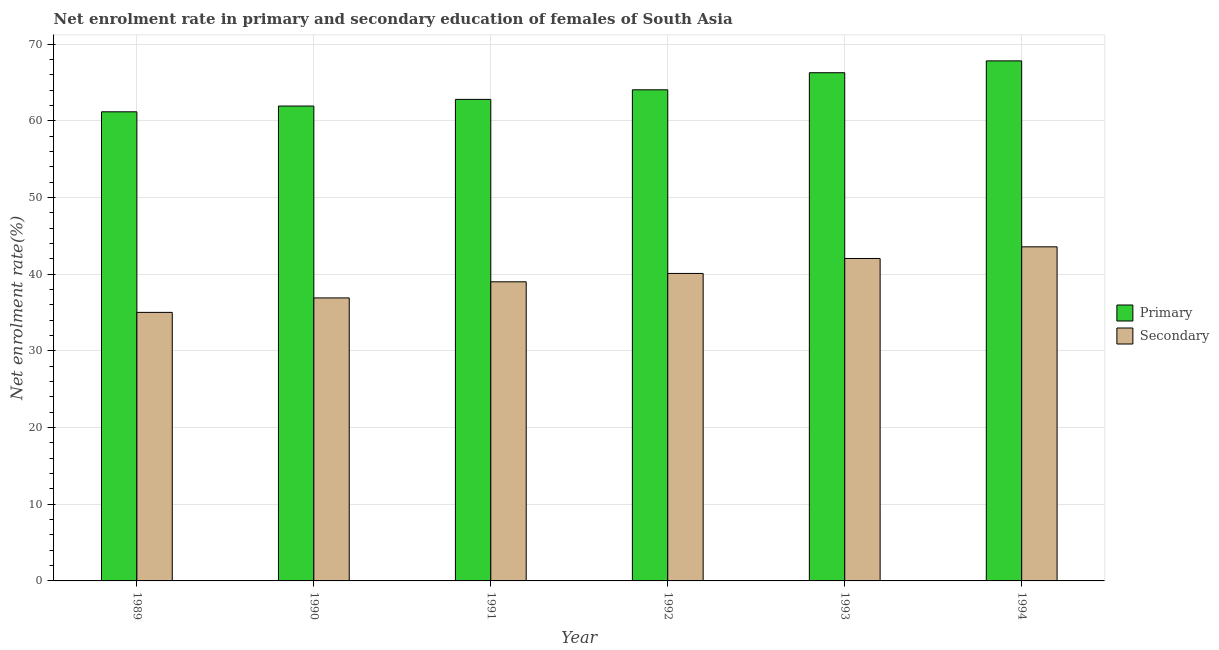How many different coloured bars are there?
Keep it short and to the point. 2. Are the number of bars per tick equal to the number of legend labels?
Your answer should be very brief. Yes. How many bars are there on the 5th tick from the left?
Your answer should be compact. 2. What is the label of the 6th group of bars from the left?
Ensure brevity in your answer.  1994. In how many cases, is the number of bars for a given year not equal to the number of legend labels?
Your response must be concise. 0. What is the enrollment rate in primary education in 1994?
Your answer should be very brief. 67.82. Across all years, what is the maximum enrollment rate in secondary education?
Offer a very short reply. 43.57. Across all years, what is the minimum enrollment rate in secondary education?
Ensure brevity in your answer.  35.02. In which year was the enrollment rate in secondary education maximum?
Your answer should be compact. 1994. In which year was the enrollment rate in primary education minimum?
Offer a terse response. 1989. What is the total enrollment rate in primary education in the graph?
Give a very brief answer. 384.06. What is the difference between the enrollment rate in primary education in 1990 and that in 1991?
Provide a short and direct response. -0.87. What is the difference between the enrollment rate in secondary education in 1990 and the enrollment rate in primary education in 1991?
Offer a very short reply. -2.1. What is the average enrollment rate in secondary education per year?
Your response must be concise. 39.44. In how many years, is the enrollment rate in primary education greater than 18 %?
Keep it short and to the point. 6. What is the ratio of the enrollment rate in secondary education in 1989 to that in 1991?
Your response must be concise. 0.9. What is the difference between the highest and the second highest enrollment rate in secondary education?
Your response must be concise. 1.52. What is the difference between the highest and the lowest enrollment rate in primary education?
Ensure brevity in your answer.  6.64. Is the sum of the enrollment rate in secondary education in 1993 and 1994 greater than the maximum enrollment rate in primary education across all years?
Your answer should be compact. Yes. What does the 1st bar from the left in 1989 represents?
Give a very brief answer. Primary. What does the 2nd bar from the right in 1992 represents?
Make the answer very short. Primary. How many bars are there?
Provide a succinct answer. 12. Are all the bars in the graph horizontal?
Provide a short and direct response. No. What is the difference between two consecutive major ticks on the Y-axis?
Offer a terse response. 10. Does the graph contain any zero values?
Ensure brevity in your answer.  No. How many legend labels are there?
Your answer should be compact. 2. What is the title of the graph?
Offer a very short reply. Net enrolment rate in primary and secondary education of females of South Asia. What is the label or title of the X-axis?
Give a very brief answer. Year. What is the label or title of the Y-axis?
Provide a succinct answer. Net enrolment rate(%). What is the Net enrolment rate(%) of Primary in 1989?
Your response must be concise. 61.18. What is the Net enrolment rate(%) in Secondary in 1989?
Your answer should be compact. 35.02. What is the Net enrolment rate(%) of Primary in 1990?
Give a very brief answer. 61.93. What is the Net enrolment rate(%) of Secondary in 1990?
Provide a short and direct response. 36.91. What is the Net enrolment rate(%) in Primary in 1991?
Offer a terse response. 62.8. What is the Net enrolment rate(%) in Secondary in 1991?
Make the answer very short. 39.01. What is the Net enrolment rate(%) of Primary in 1992?
Your answer should be compact. 64.05. What is the Net enrolment rate(%) in Secondary in 1992?
Your answer should be compact. 40.1. What is the Net enrolment rate(%) of Primary in 1993?
Ensure brevity in your answer.  66.28. What is the Net enrolment rate(%) in Secondary in 1993?
Give a very brief answer. 42.05. What is the Net enrolment rate(%) of Primary in 1994?
Provide a succinct answer. 67.82. What is the Net enrolment rate(%) of Secondary in 1994?
Give a very brief answer. 43.57. Across all years, what is the maximum Net enrolment rate(%) of Primary?
Give a very brief answer. 67.82. Across all years, what is the maximum Net enrolment rate(%) of Secondary?
Make the answer very short. 43.57. Across all years, what is the minimum Net enrolment rate(%) of Primary?
Make the answer very short. 61.18. Across all years, what is the minimum Net enrolment rate(%) of Secondary?
Provide a succinct answer. 35.02. What is the total Net enrolment rate(%) of Primary in the graph?
Offer a terse response. 384.06. What is the total Net enrolment rate(%) in Secondary in the graph?
Your response must be concise. 236.66. What is the difference between the Net enrolment rate(%) in Primary in 1989 and that in 1990?
Your answer should be very brief. -0.75. What is the difference between the Net enrolment rate(%) in Secondary in 1989 and that in 1990?
Your answer should be compact. -1.89. What is the difference between the Net enrolment rate(%) in Primary in 1989 and that in 1991?
Your response must be concise. -1.62. What is the difference between the Net enrolment rate(%) in Secondary in 1989 and that in 1991?
Offer a terse response. -3.99. What is the difference between the Net enrolment rate(%) in Primary in 1989 and that in 1992?
Provide a succinct answer. -2.87. What is the difference between the Net enrolment rate(%) in Secondary in 1989 and that in 1992?
Keep it short and to the point. -5.08. What is the difference between the Net enrolment rate(%) of Primary in 1989 and that in 1993?
Provide a succinct answer. -5.1. What is the difference between the Net enrolment rate(%) in Secondary in 1989 and that in 1993?
Your response must be concise. -7.03. What is the difference between the Net enrolment rate(%) in Primary in 1989 and that in 1994?
Provide a succinct answer. -6.64. What is the difference between the Net enrolment rate(%) of Secondary in 1989 and that in 1994?
Offer a very short reply. -8.55. What is the difference between the Net enrolment rate(%) in Primary in 1990 and that in 1991?
Ensure brevity in your answer.  -0.87. What is the difference between the Net enrolment rate(%) of Secondary in 1990 and that in 1991?
Offer a very short reply. -2.1. What is the difference between the Net enrolment rate(%) in Primary in 1990 and that in 1992?
Your answer should be very brief. -2.12. What is the difference between the Net enrolment rate(%) of Secondary in 1990 and that in 1992?
Your answer should be very brief. -3.19. What is the difference between the Net enrolment rate(%) in Primary in 1990 and that in 1993?
Offer a terse response. -4.35. What is the difference between the Net enrolment rate(%) of Secondary in 1990 and that in 1993?
Your answer should be compact. -5.14. What is the difference between the Net enrolment rate(%) in Primary in 1990 and that in 1994?
Your answer should be compact. -5.89. What is the difference between the Net enrolment rate(%) of Secondary in 1990 and that in 1994?
Make the answer very short. -6.66. What is the difference between the Net enrolment rate(%) of Primary in 1991 and that in 1992?
Make the answer very short. -1.25. What is the difference between the Net enrolment rate(%) in Secondary in 1991 and that in 1992?
Your response must be concise. -1.09. What is the difference between the Net enrolment rate(%) of Primary in 1991 and that in 1993?
Your answer should be very brief. -3.48. What is the difference between the Net enrolment rate(%) in Secondary in 1991 and that in 1993?
Make the answer very short. -3.04. What is the difference between the Net enrolment rate(%) in Primary in 1991 and that in 1994?
Your answer should be very brief. -5.02. What is the difference between the Net enrolment rate(%) in Secondary in 1991 and that in 1994?
Your answer should be very brief. -4.56. What is the difference between the Net enrolment rate(%) of Primary in 1992 and that in 1993?
Give a very brief answer. -2.23. What is the difference between the Net enrolment rate(%) in Secondary in 1992 and that in 1993?
Provide a succinct answer. -1.95. What is the difference between the Net enrolment rate(%) in Primary in 1992 and that in 1994?
Provide a short and direct response. -3.77. What is the difference between the Net enrolment rate(%) in Secondary in 1992 and that in 1994?
Make the answer very short. -3.47. What is the difference between the Net enrolment rate(%) in Primary in 1993 and that in 1994?
Your answer should be compact. -1.54. What is the difference between the Net enrolment rate(%) of Secondary in 1993 and that in 1994?
Your answer should be very brief. -1.52. What is the difference between the Net enrolment rate(%) in Primary in 1989 and the Net enrolment rate(%) in Secondary in 1990?
Keep it short and to the point. 24.27. What is the difference between the Net enrolment rate(%) of Primary in 1989 and the Net enrolment rate(%) of Secondary in 1991?
Keep it short and to the point. 22.17. What is the difference between the Net enrolment rate(%) in Primary in 1989 and the Net enrolment rate(%) in Secondary in 1992?
Provide a short and direct response. 21.08. What is the difference between the Net enrolment rate(%) in Primary in 1989 and the Net enrolment rate(%) in Secondary in 1993?
Your response must be concise. 19.13. What is the difference between the Net enrolment rate(%) in Primary in 1989 and the Net enrolment rate(%) in Secondary in 1994?
Your response must be concise. 17.61. What is the difference between the Net enrolment rate(%) in Primary in 1990 and the Net enrolment rate(%) in Secondary in 1991?
Offer a terse response. 22.92. What is the difference between the Net enrolment rate(%) in Primary in 1990 and the Net enrolment rate(%) in Secondary in 1992?
Ensure brevity in your answer.  21.83. What is the difference between the Net enrolment rate(%) of Primary in 1990 and the Net enrolment rate(%) of Secondary in 1993?
Your answer should be compact. 19.88. What is the difference between the Net enrolment rate(%) in Primary in 1990 and the Net enrolment rate(%) in Secondary in 1994?
Ensure brevity in your answer.  18.36. What is the difference between the Net enrolment rate(%) of Primary in 1991 and the Net enrolment rate(%) of Secondary in 1992?
Make the answer very short. 22.7. What is the difference between the Net enrolment rate(%) in Primary in 1991 and the Net enrolment rate(%) in Secondary in 1993?
Provide a short and direct response. 20.75. What is the difference between the Net enrolment rate(%) in Primary in 1991 and the Net enrolment rate(%) in Secondary in 1994?
Provide a succinct answer. 19.23. What is the difference between the Net enrolment rate(%) in Primary in 1992 and the Net enrolment rate(%) in Secondary in 1993?
Your answer should be very brief. 22. What is the difference between the Net enrolment rate(%) of Primary in 1992 and the Net enrolment rate(%) of Secondary in 1994?
Give a very brief answer. 20.48. What is the difference between the Net enrolment rate(%) of Primary in 1993 and the Net enrolment rate(%) of Secondary in 1994?
Offer a terse response. 22.71. What is the average Net enrolment rate(%) in Primary per year?
Keep it short and to the point. 64.01. What is the average Net enrolment rate(%) of Secondary per year?
Ensure brevity in your answer.  39.44. In the year 1989, what is the difference between the Net enrolment rate(%) in Primary and Net enrolment rate(%) in Secondary?
Ensure brevity in your answer.  26.16. In the year 1990, what is the difference between the Net enrolment rate(%) in Primary and Net enrolment rate(%) in Secondary?
Your response must be concise. 25.02. In the year 1991, what is the difference between the Net enrolment rate(%) in Primary and Net enrolment rate(%) in Secondary?
Make the answer very short. 23.79. In the year 1992, what is the difference between the Net enrolment rate(%) in Primary and Net enrolment rate(%) in Secondary?
Give a very brief answer. 23.95. In the year 1993, what is the difference between the Net enrolment rate(%) in Primary and Net enrolment rate(%) in Secondary?
Give a very brief answer. 24.23. In the year 1994, what is the difference between the Net enrolment rate(%) in Primary and Net enrolment rate(%) in Secondary?
Ensure brevity in your answer.  24.25. What is the ratio of the Net enrolment rate(%) of Primary in 1989 to that in 1990?
Make the answer very short. 0.99. What is the ratio of the Net enrolment rate(%) of Secondary in 1989 to that in 1990?
Give a very brief answer. 0.95. What is the ratio of the Net enrolment rate(%) of Primary in 1989 to that in 1991?
Your response must be concise. 0.97. What is the ratio of the Net enrolment rate(%) in Secondary in 1989 to that in 1991?
Make the answer very short. 0.9. What is the ratio of the Net enrolment rate(%) of Primary in 1989 to that in 1992?
Give a very brief answer. 0.96. What is the ratio of the Net enrolment rate(%) of Secondary in 1989 to that in 1992?
Offer a very short reply. 0.87. What is the ratio of the Net enrolment rate(%) in Secondary in 1989 to that in 1993?
Keep it short and to the point. 0.83. What is the ratio of the Net enrolment rate(%) in Primary in 1989 to that in 1994?
Keep it short and to the point. 0.9. What is the ratio of the Net enrolment rate(%) in Secondary in 1989 to that in 1994?
Make the answer very short. 0.8. What is the ratio of the Net enrolment rate(%) in Primary in 1990 to that in 1991?
Give a very brief answer. 0.99. What is the ratio of the Net enrolment rate(%) in Secondary in 1990 to that in 1991?
Make the answer very short. 0.95. What is the ratio of the Net enrolment rate(%) of Primary in 1990 to that in 1992?
Make the answer very short. 0.97. What is the ratio of the Net enrolment rate(%) in Secondary in 1990 to that in 1992?
Provide a short and direct response. 0.92. What is the ratio of the Net enrolment rate(%) in Primary in 1990 to that in 1993?
Give a very brief answer. 0.93. What is the ratio of the Net enrolment rate(%) in Secondary in 1990 to that in 1993?
Your response must be concise. 0.88. What is the ratio of the Net enrolment rate(%) in Primary in 1990 to that in 1994?
Your answer should be very brief. 0.91. What is the ratio of the Net enrolment rate(%) of Secondary in 1990 to that in 1994?
Offer a terse response. 0.85. What is the ratio of the Net enrolment rate(%) of Primary in 1991 to that in 1992?
Give a very brief answer. 0.98. What is the ratio of the Net enrolment rate(%) of Secondary in 1991 to that in 1992?
Ensure brevity in your answer.  0.97. What is the ratio of the Net enrolment rate(%) in Primary in 1991 to that in 1993?
Your answer should be very brief. 0.95. What is the ratio of the Net enrolment rate(%) of Secondary in 1991 to that in 1993?
Your response must be concise. 0.93. What is the ratio of the Net enrolment rate(%) of Primary in 1991 to that in 1994?
Give a very brief answer. 0.93. What is the ratio of the Net enrolment rate(%) in Secondary in 1991 to that in 1994?
Make the answer very short. 0.9. What is the ratio of the Net enrolment rate(%) in Primary in 1992 to that in 1993?
Offer a very short reply. 0.97. What is the ratio of the Net enrolment rate(%) in Secondary in 1992 to that in 1993?
Offer a terse response. 0.95. What is the ratio of the Net enrolment rate(%) of Secondary in 1992 to that in 1994?
Make the answer very short. 0.92. What is the ratio of the Net enrolment rate(%) of Primary in 1993 to that in 1994?
Ensure brevity in your answer.  0.98. What is the ratio of the Net enrolment rate(%) of Secondary in 1993 to that in 1994?
Your answer should be compact. 0.97. What is the difference between the highest and the second highest Net enrolment rate(%) of Primary?
Provide a succinct answer. 1.54. What is the difference between the highest and the second highest Net enrolment rate(%) in Secondary?
Offer a terse response. 1.52. What is the difference between the highest and the lowest Net enrolment rate(%) of Primary?
Keep it short and to the point. 6.64. What is the difference between the highest and the lowest Net enrolment rate(%) of Secondary?
Give a very brief answer. 8.55. 